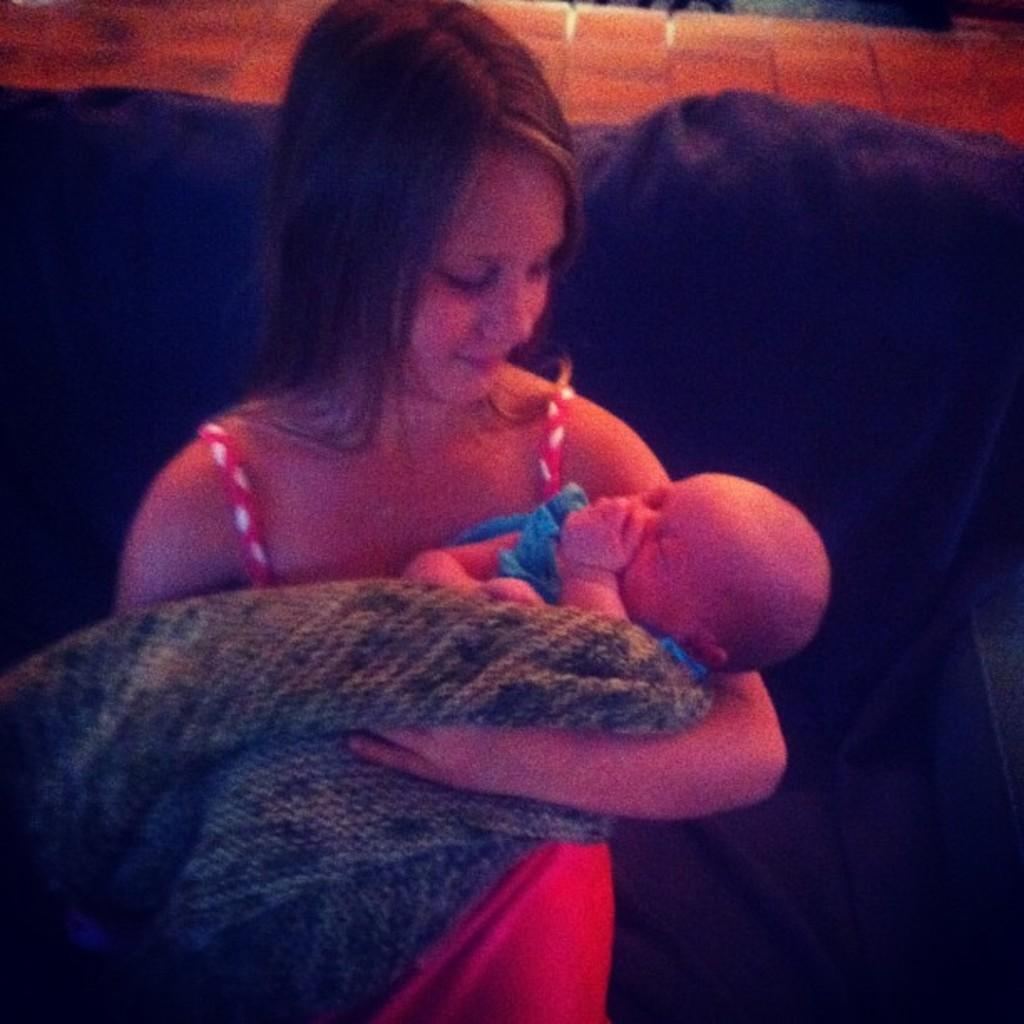Who is present in the image? There is a woman in the image. What is the woman doing in the image? The woman is holding a baby. Where are the woman and the baby sitting in the image? Both the woman and the baby are sitting on a couch. What type of wax is being used to create the baby's hair in the image? There is no wax present in the image, and the baby's hair is not made of wax. 